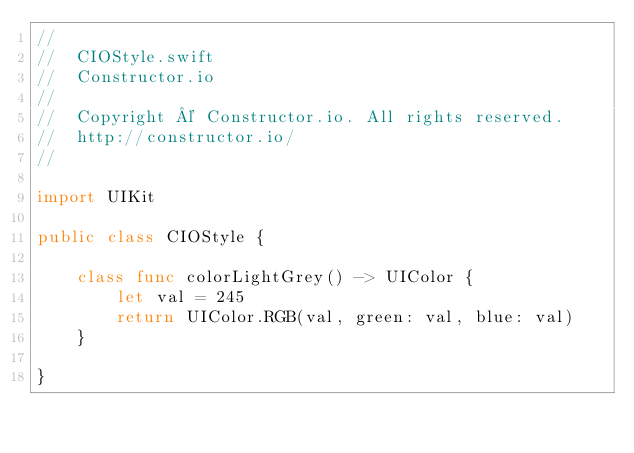<code> <loc_0><loc_0><loc_500><loc_500><_Swift_>//
//  CIOStyle.swift
//  Constructor.io
//
//  Copyright © Constructor.io. All rights reserved.
//  http://constructor.io/
//

import UIKit

public class CIOStyle {

    class func colorLightGrey() -> UIColor {
        let val = 245
        return UIColor.RGB(val, green: val, blue: val)
    }

}
</code> 